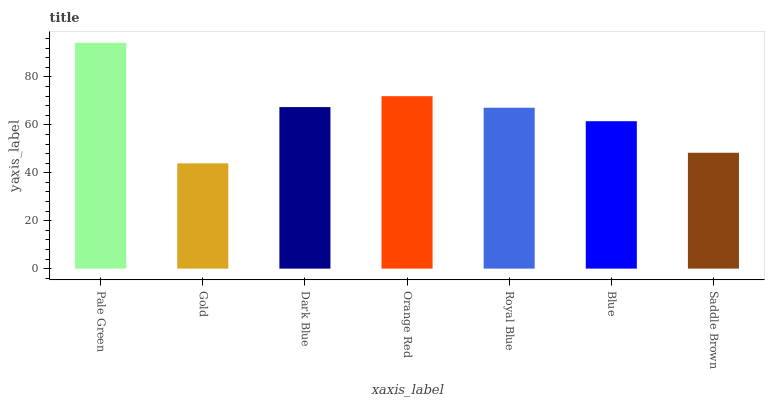Is Gold the minimum?
Answer yes or no. Yes. Is Pale Green the maximum?
Answer yes or no. Yes. Is Dark Blue the minimum?
Answer yes or no. No. Is Dark Blue the maximum?
Answer yes or no. No. Is Dark Blue greater than Gold?
Answer yes or no. Yes. Is Gold less than Dark Blue?
Answer yes or no. Yes. Is Gold greater than Dark Blue?
Answer yes or no. No. Is Dark Blue less than Gold?
Answer yes or no. No. Is Royal Blue the high median?
Answer yes or no. Yes. Is Royal Blue the low median?
Answer yes or no. Yes. Is Orange Red the high median?
Answer yes or no. No. Is Orange Red the low median?
Answer yes or no. No. 